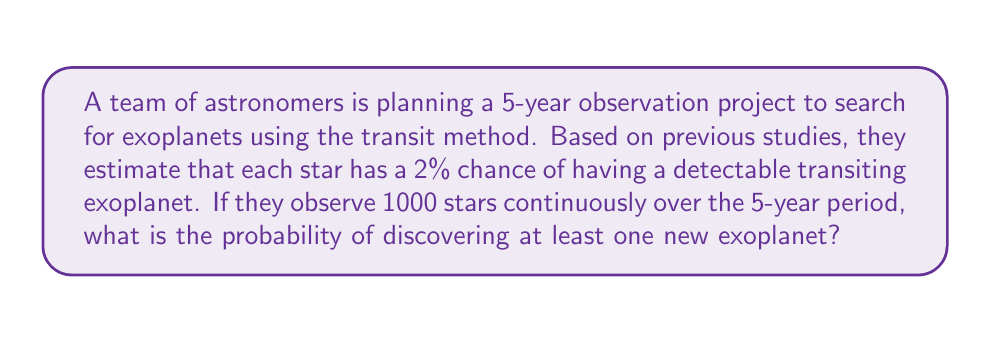Can you solve this math problem? Let's approach this step-by-step:

1) First, we need to calculate the probability of not discovering an exoplanet around a single star:
   $P(\text{no exoplanet}) = 1 - P(\text{exoplanet}) = 1 - 0.02 = 0.98$

2) Now, we need to find the probability of not discovering an exoplanet around any of the 1000 stars:
   $P(\text{no exoplanets in 1000 stars}) = (0.98)^{1000}$

3) We can calculate this using logarithms:
   $\log(0.98^{1000}) = 1000 \log(0.98) = 1000 \times (-0.008710636) = -8.710636$

4) Therefore, $0.98^{1000} = 10^{-8.710636} \approx 1.95 \times 10^{-9}$

5) The probability of discovering at least one exoplanet is the complement of finding no exoplanets:
   $P(\text{at least one exoplanet}) = 1 - P(\text{no exoplanets in 1000 stars})$
   $= 1 - (1.95 \times 10^{-9}) \approx 0.999999998$

6) Converting to a percentage:
   $0.999999998 \times 100\% \approx 99.9999998\%$
Answer: $99.9999998\%$ 